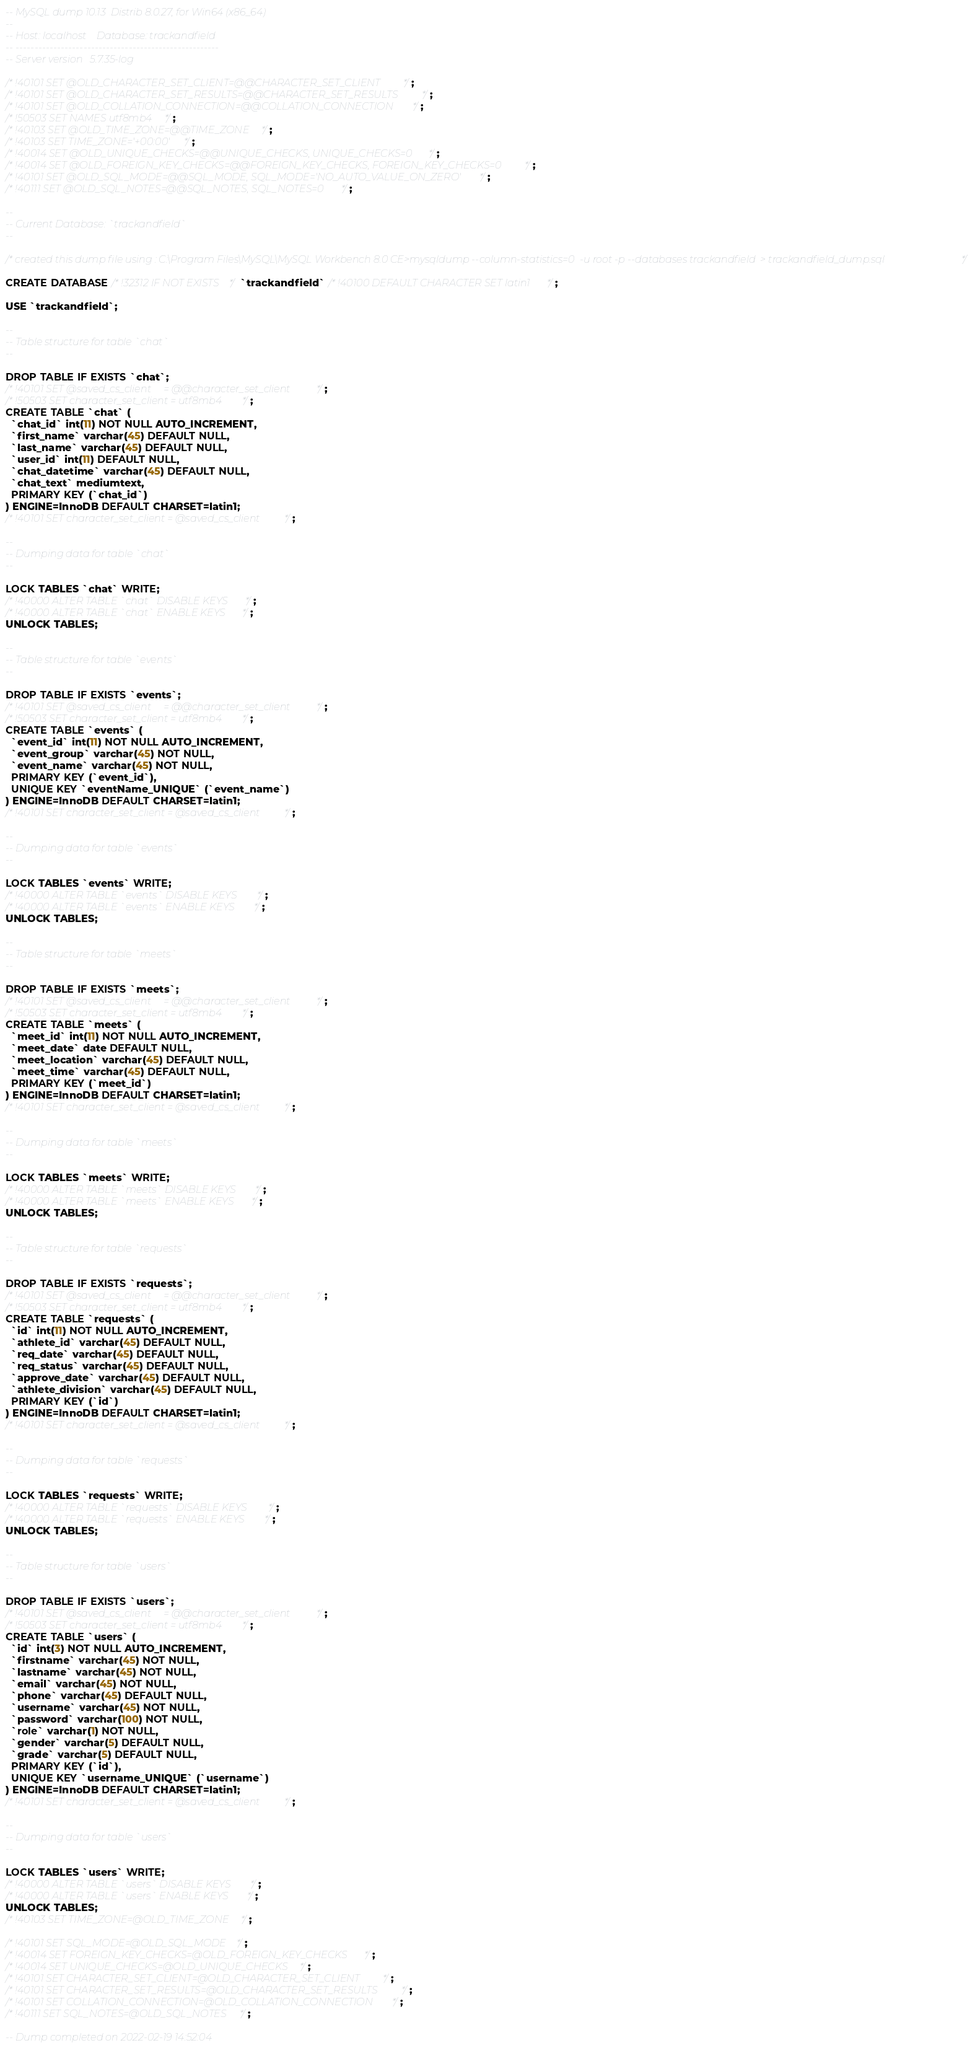<code> <loc_0><loc_0><loc_500><loc_500><_SQL_>-- MySQL dump 10.13  Distrib 8.0.27, for Win64 (x86_64)
--
-- Host: localhost    Database: trackandfield
-- ------------------------------------------------------
-- Server version	5.7.35-log

/*!40101 SET @OLD_CHARACTER_SET_CLIENT=@@CHARACTER_SET_CLIENT */;
/*!40101 SET @OLD_CHARACTER_SET_RESULTS=@@CHARACTER_SET_RESULTS */;
/*!40101 SET @OLD_COLLATION_CONNECTION=@@COLLATION_CONNECTION */;
/*!50503 SET NAMES utf8mb4 */;
/*!40103 SET @OLD_TIME_ZONE=@@TIME_ZONE */;
/*!40103 SET TIME_ZONE='+00:00' */;
/*!40014 SET @OLD_UNIQUE_CHECKS=@@UNIQUE_CHECKS, UNIQUE_CHECKS=0 */;
/*!40014 SET @OLD_FOREIGN_KEY_CHECKS=@@FOREIGN_KEY_CHECKS, FOREIGN_KEY_CHECKS=0 */;
/*!40101 SET @OLD_SQL_MODE=@@SQL_MODE, SQL_MODE='NO_AUTO_VALUE_ON_ZERO' */;
/*!40111 SET @OLD_SQL_NOTES=@@SQL_NOTES, SQL_NOTES=0 */;

--
-- Current Database: `trackandfield`
--

/*created this dump file using : C:\Program Files\MySQL\MySQL Workbench 8.0 CE>mysqldump --column-statistics=0  -u root -p --databases trackandfield  > trackandfield_dump.sql*/

CREATE DATABASE /*!32312 IF NOT EXISTS*/ `trackandfield` /*!40100 DEFAULT CHARACTER SET latin1 */;

USE `trackandfield`;

--
-- Table structure for table `chat`
--

DROP TABLE IF EXISTS `chat`;
/*!40101 SET @saved_cs_client     = @@character_set_client */;
/*!50503 SET character_set_client = utf8mb4 */;
CREATE TABLE `chat` (
  `chat_id` int(11) NOT NULL AUTO_INCREMENT,
  `first_name` varchar(45) DEFAULT NULL,
  `last_name` varchar(45) DEFAULT NULL,
  `user_id` int(11) DEFAULT NULL,
  `chat_datetime` varchar(45) DEFAULT NULL,
  `chat_text` mediumtext,
  PRIMARY KEY (`chat_id`)
) ENGINE=InnoDB DEFAULT CHARSET=latin1;
/*!40101 SET character_set_client = @saved_cs_client */;

--
-- Dumping data for table `chat`
--

LOCK TABLES `chat` WRITE;
/*!40000 ALTER TABLE `chat` DISABLE KEYS */;
/*!40000 ALTER TABLE `chat` ENABLE KEYS */;
UNLOCK TABLES;

--
-- Table structure for table `events`
--

DROP TABLE IF EXISTS `events`;
/*!40101 SET @saved_cs_client     = @@character_set_client */;
/*!50503 SET character_set_client = utf8mb4 */;
CREATE TABLE `events` (
  `event_id` int(11) NOT NULL AUTO_INCREMENT,
  `event_group` varchar(45) NOT NULL,
  `event_name` varchar(45) NOT NULL,
  PRIMARY KEY (`event_id`),
  UNIQUE KEY `eventName_UNIQUE` (`event_name`)
) ENGINE=InnoDB DEFAULT CHARSET=latin1;
/*!40101 SET character_set_client = @saved_cs_client */;

--
-- Dumping data for table `events`
--

LOCK TABLES `events` WRITE;
/*!40000 ALTER TABLE `events` DISABLE KEYS */;
/*!40000 ALTER TABLE `events` ENABLE KEYS */;
UNLOCK TABLES;

--
-- Table structure for table `meets`
--

DROP TABLE IF EXISTS `meets`;
/*!40101 SET @saved_cs_client     = @@character_set_client */;
/*!50503 SET character_set_client = utf8mb4 */;
CREATE TABLE `meets` (
  `meet_id` int(11) NOT NULL AUTO_INCREMENT,
  `meet_date` date DEFAULT NULL,
  `meet_location` varchar(45) DEFAULT NULL,
  `meet_time` varchar(45) DEFAULT NULL,
  PRIMARY KEY (`meet_id`)
) ENGINE=InnoDB DEFAULT CHARSET=latin1;
/*!40101 SET character_set_client = @saved_cs_client */;

--
-- Dumping data for table `meets`
--

LOCK TABLES `meets` WRITE;
/*!40000 ALTER TABLE `meets` DISABLE KEYS */;
/*!40000 ALTER TABLE `meets` ENABLE KEYS */;
UNLOCK TABLES;

--
-- Table structure for table `requests`
--

DROP TABLE IF EXISTS `requests`;
/*!40101 SET @saved_cs_client     = @@character_set_client */;
/*!50503 SET character_set_client = utf8mb4 */;
CREATE TABLE `requests` (
  `id` int(11) NOT NULL AUTO_INCREMENT,
  `athlete_id` varchar(45) DEFAULT NULL,
  `req_date` varchar(45) DEFAULT NULL,
  `req_status` varchar(45) DEFAULT NULL,
  `approve_date` varchar(45) DEFAULT NULL,
  `athlete_division` varchar(45) DEFAULT NULL,
  PRIMARY KEY (`id`)
) ENGINE=InnoDB DEFAULT CHARSET=latin1;
/*!40101 SET character_set_client = @saved_cs_client */;

--
-- Dumping data for table `requests`
--

LOCK TABLES `requests` WRITE;
/*!40000 ALTER TABLE `requests` DISABLE KEYS */;
/*!40000 ALTER TABLE `requests` ENABLE KEYS */;
UNLOCK TABLES;

--
-- Table structure for table `users`
--

DROP TABLE IF EXISTS `users`;
/*!40101 SET @saved_cs_client     = @@character_set_client */;
/*!50503 SET character_set_client = utf8mb4 */;
CREATE TABLE `users` (
  `id` int(3) NOT NULL AUTO_INCREMENT,
  `firstname` varchar(45) NOT NULL,
  `lastname` varchar(45) NOT NULL,
  `email` varchar(45) NOT NULL,
  `phone` varchar(45) DEFAULT NULL,
  `username` varchar(45) NOT NULL,
  `password` varchar(100) NOT NULL,
  `role` varchar(1) NOT NULL,
  `gender` varchar(5) DEFAULT NULL,
  `grade` varchar(5) DEFAULT NULL,
  PRIMARY KEY (`id`),
  UNIQUE KEY `username_UNIQUE` (`username`)
) ENGINE=InnoDB DEFAULT CHARSET=latin1;
/*!40101 SET character_set_client = @saved_cs_client */;

--
-- Dumping data for table `users`
--

LOCK TABLES `users` WRITE;
/*!40000 ALTER TABLE `users` DISABLE KEYS */;
/*!40000 ALTER TABLE `users` ENABLE KEYS */;
UNLOCK TABLES;
/*!40103 SET TIME_ZONE=@OLD_TIME_ZONE */;

/*!40101 SET SQL_MODE=@OLD_SQL_MODE */;
/*!40014 SET FOREIGN_KEY_CHECKS=@OLD_FOREIGN_KEY_CHECKS */;
/*!40014 SET UNIQUE_CHECKS=@OLD_UNIQUE_CHECKS */;
/*!40101 SET CHARACTER_SET_CLIENT=@OLD_CHARACTER_SET_CLIENT */;
/*!40101 SET CHARACTER_SET_RESULTS=@OLD_CHARACTER_SET_RESULTS */;
/*!40101 SET COLLATION_CONNECTION=@OLD_COLLATION_CONNECTION */;
/*!40111 SET SQL_NOTES=@OLD_SQL_NOTES */;

-- Dump completed on 2022-02-19 14:52:04
</code> 